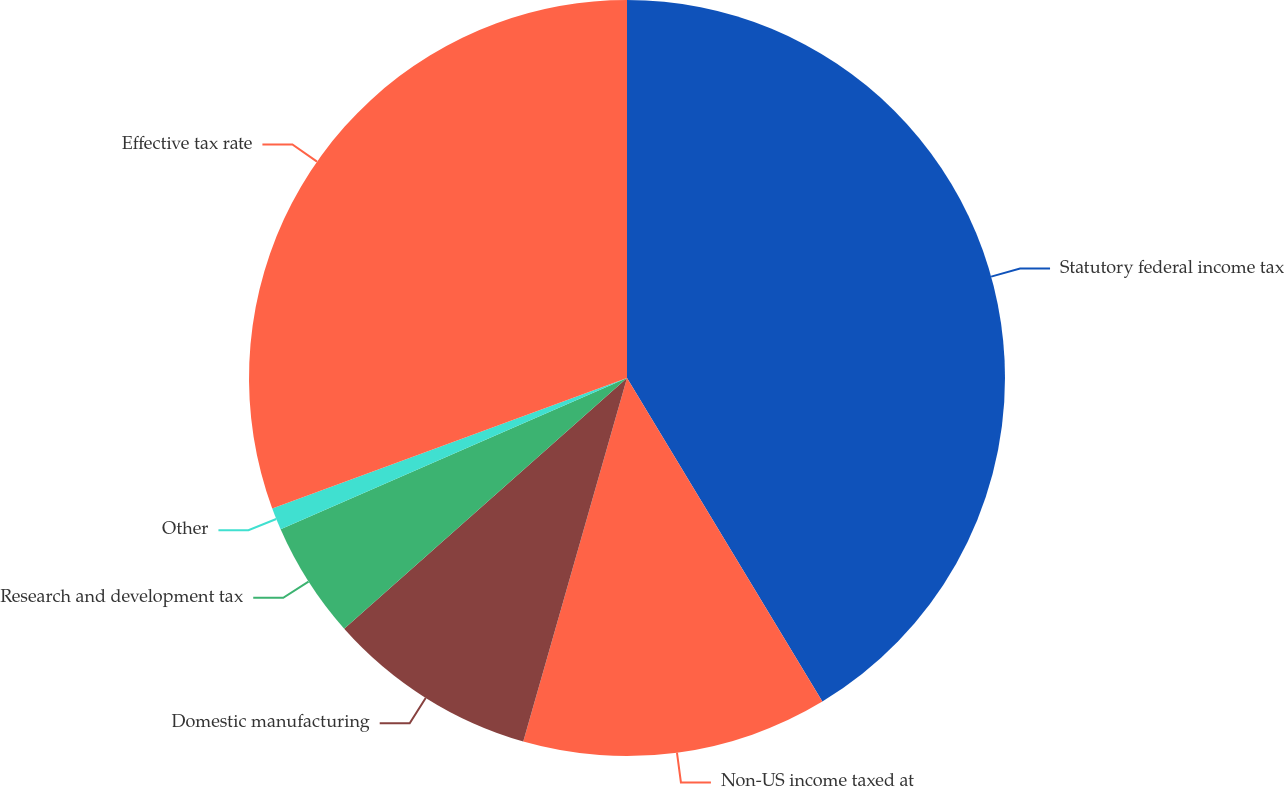Convert chart. <chart><loc_0><loc_0><loc_500><loc_500><pie_chart><fcel>Statutory federal income tax<fcel>Non-US income taxed at<fcel>Domestic manufacturing<fcel>Research and development tax<fcel>Other<fcel>Effective tax rate<nl><fcel>41.36%<fcel>13.07%<fcel>9.03%<fcel>4.99%<fcel>0.95%<fcel>30.61%<nl></chart> 